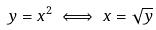Convert formula to latex. <formula><loc_0><loc_0><loc_500><loc_500>y = x ^ { 2 } \iff x = \sqrt { y }</formula> 